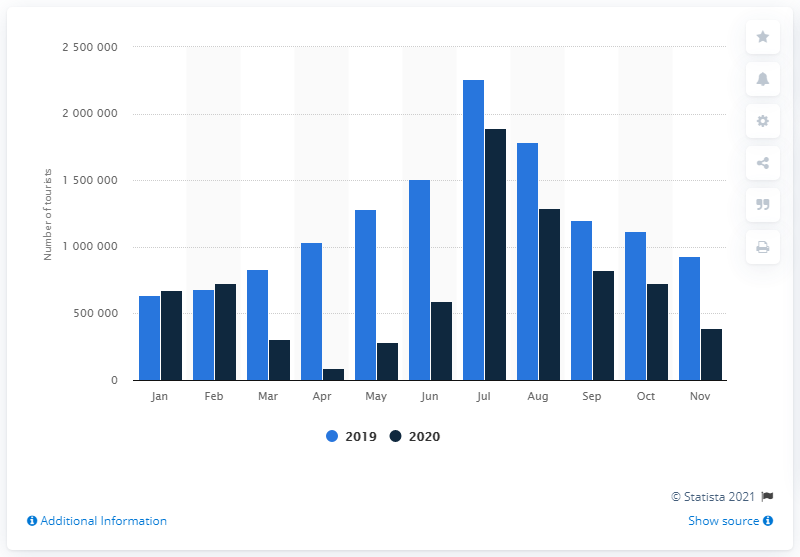List a handful of essential elements in this visual. In November 2019, a total of 933,525 tourists visited Denmark. In April 2020, a total of 87,121 tourists visited Denmark. In November 2020, a total of 393,059 people traveled to Denmark. 